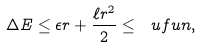<formula> <loc_0><loc_0><loc_500><loc_500>\Delta E \leq \epsilon r + \frac { \ell r ^ { 2 } } { 2 } \leq \ u f u n ,</formula> 